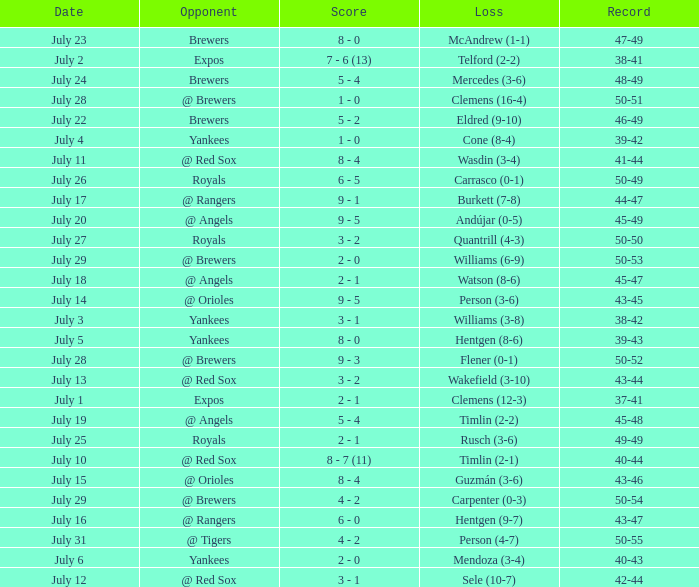What's the record on july 10? 40-44. Could you parse the entire table? {'header': ['Date', 'Opponent', 'Score', 'Loss', 'Record'], 'rows': [['July 23', 'Brewers', '8 - 0', 'McAndrew (1-1)', '47-49'], ['July 2', 'Expos', '7 - 6 (13)', 'Telford (2-2)', '38-41'], ['July 24', 'Brewers', '5 - 4', 'Mercedes (3-6)', '48-49'], ['July 28', '@ Brewers', '1 - 0', 'Clemens (16-4)', '50-51'], ['July 22', 'Brewers', '5 - 2', 'Eldred (9-10)', '46-49'], ['July 4', 'Yankees', '1 - 0', 'Cone (8-4)', '39-42'], ['July 11', '@ Red Sox', '8 - 4', 'Wasdin (3-4)', '41-44'], ['July 26', 'Royals', '6 - 5', 'Carrasco (0-1)', '50-49'], ['July 17', '@ Rangers', '9 - 1', 'Burkett (7-8)', '44-47'], ['July 20', '@ Angels', '9 - 5', 'Andújar (0-5)', '45-49'], ['July 27', 'Royals', '3 - 2', 'Quantrill (4-3)', '50-50'], ['July 29', '@ Brewers', '2 - 0', 'Williams (6-9)', '50-53'], ['July 18', '@ Angels', '2 - 1', 'Watson (8-6)', '45-47'], ['July 14', '@ Orioles', '9 - 5', 'Person (3-6)', '43-45'], ['July 3', 'Yankees', '3 - 1', 'Williams (3-8)', '38-42'], ['July 5', 'Yankees', '8 - 0', 'Hentgen (8-6)', '39-43'], ['July 28', '@ Brewers', '9 - 3', 'Flener (0-1)', '50-52'], ['July 13', '@ Red Sox', '3 - 2', 'Wakefield (3-10)', '43-44'], ['July 1', 'Expos', '2 - 1', 'Clemens (12-3)', '37-41'], ['July 19', '@ Angels', '5 - 4', 'Timlin (2-2)', '45-48'], ['July 25', 'Royals', '2 - 1', 'Rusch (3-6)', '49-49'], ['July 10', '@ Red Sox', '8 - 7 (11)', 'Timlin (2-1)', '40-44'], ['July 15', '@ Orioles', '8 - 4', 'Guzmán (3-6)', '43-46'], ['July 29', '@ Brewers', '4 - 2', 'Carpenter (0-3)', '50-54'], ['July 16', '@ Rangers', '6 - 0', 'Hentgen (9-7)', '43-47'], ['July 31', '@ Tigers', '4 - 2', 'Person (4-7)', '50-55'], ['July 6', 'Yankees', '2 - 0', 'Mendoza (3-4)', '40-43'], ['July 12', '@ Red Sox', '3 - 1', 'Sele (10-7)', '42-44']]} 